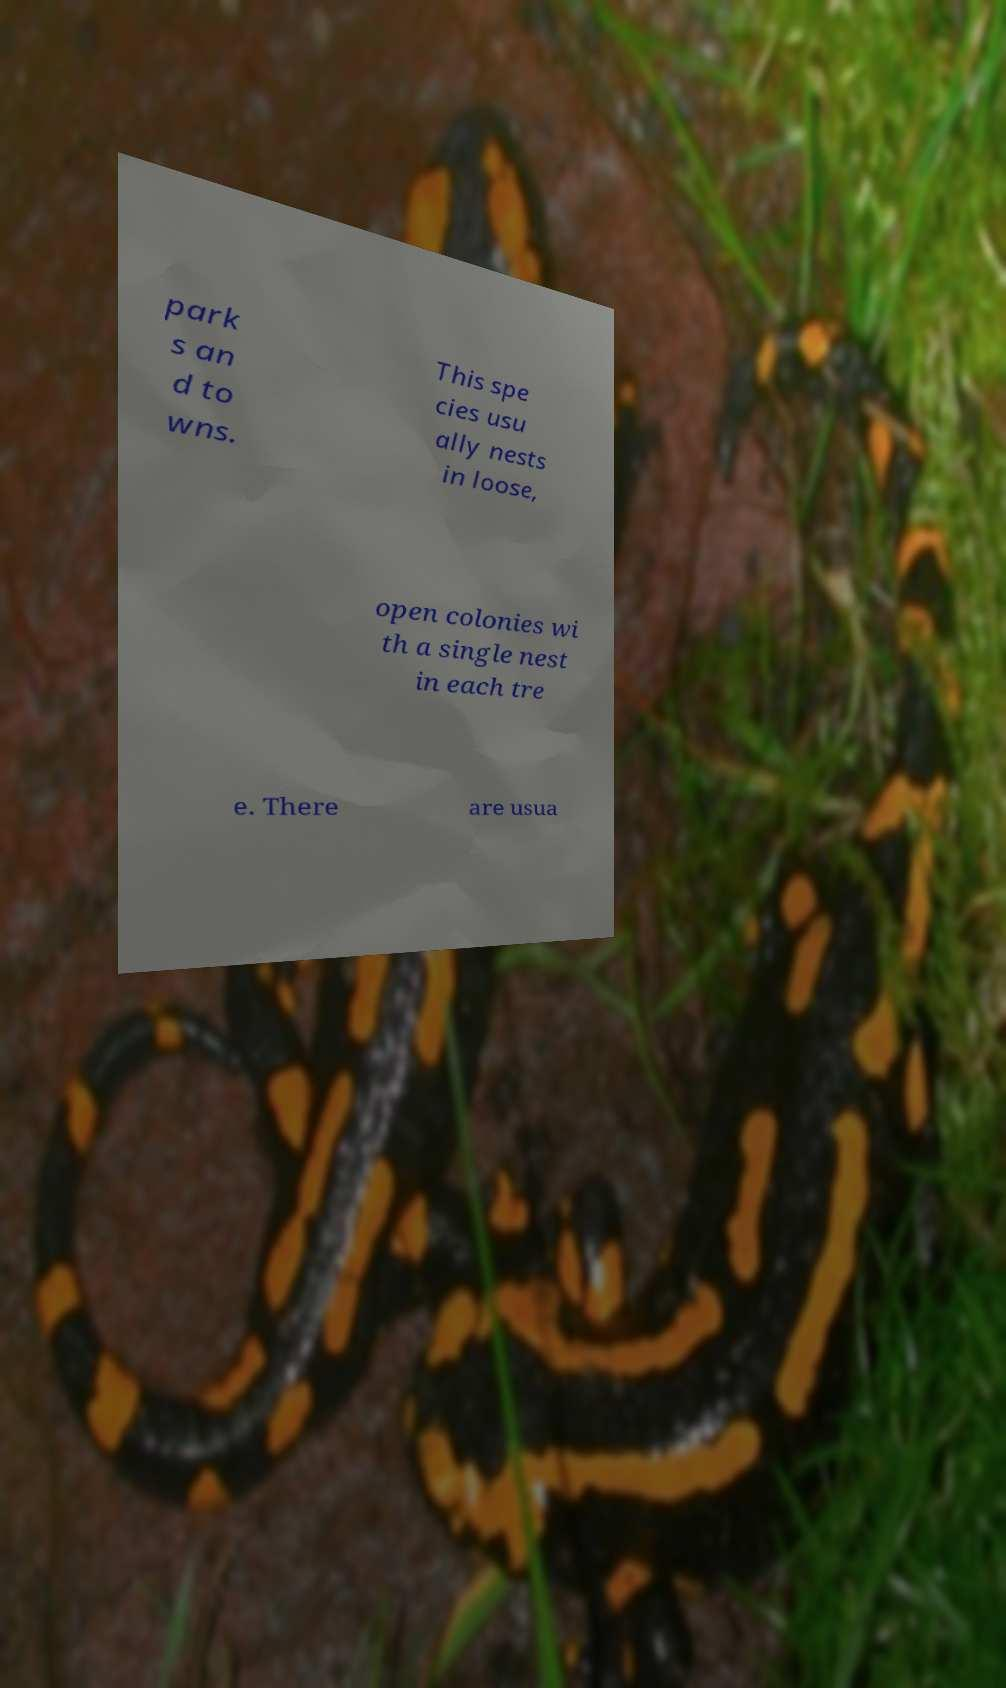Can you read and provide the text displayed in the image?This photo seems to have some interesting text. Can you extract and type it out for me? park s an d to wns. This spe cies usu ally nests in loose, open colonies wi th a single nest in each tre e. There are usua 